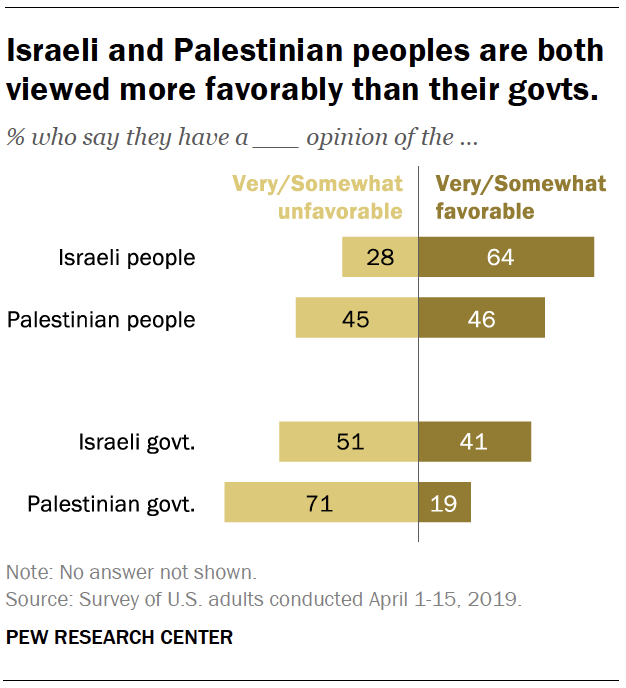Give some essential details in this illustration. The Israeli government is viewed more favorably by U.S. citizens than the Palestinian government, according to recent polls. The highest value shown in the bar graph is 71. 